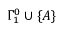<formula> <loc_0><loc_0><loc_500><loc_500>\Gamma _ { 1 } ^ { 0 } \cup \{ A \}</formula> 